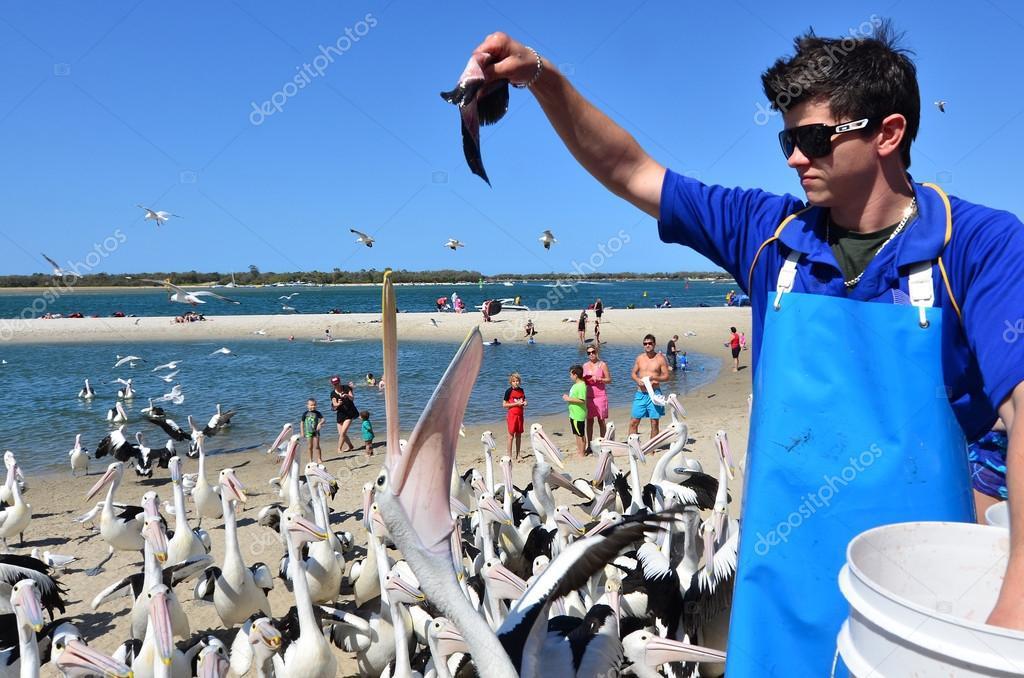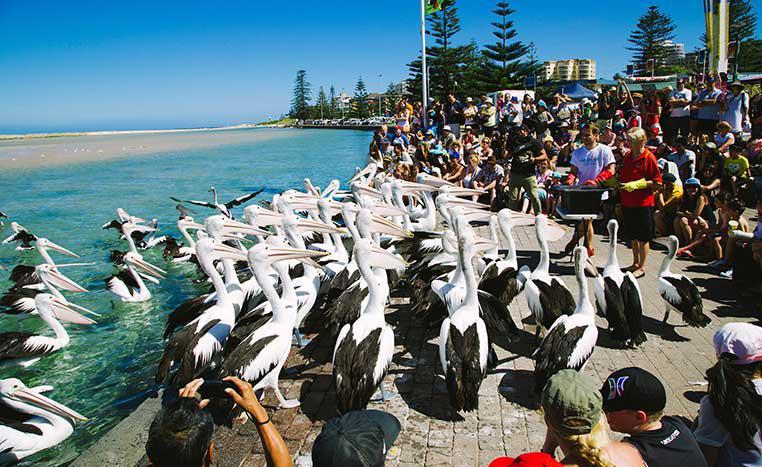The first image is the image on the left, the second image is the image on the right. Evaluate the accuracy of this statement regarding the images: "At least one pelican has its mouth open.". Is it true? Answer yes or no. Yes. The first image is the image on the left, the second image is the image on the right. Analyze the images presented: Is the assertion "In one of the photos in each pair is a man in a blue shirt surrounded by many pelicans and he is feeding them." valid? Answer yes or no. Yes. 